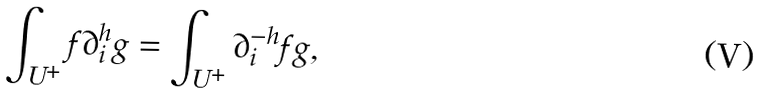<formula> <loc_0><loc_0><loc_500><loc_500>\int _ { U ^ { + } } f \partial ^ { h } _ { i } g = \int _ { U ^ { + } } \partial ^ { - h } _ { i } f g ,</formula> 